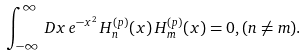<formula> <loc_0><loc_0><loc_500><loc_500>\int _ { - \infty } ^ { \infty } \, D x \, e ^ { - x ^ { 2 } } \, H _ { n } ^ { ( p ) } ( x ) \, H _ { m } ^ { ( p ) } ( x ) = 0 , ( n \neq m ) .</formula> 